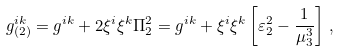<formula> <loc_0><loc_0><loc_500><loc_500>g ^ { i k } _ { ( 2 ) } = g ^ { i k } + 2 \xi ^ { i } \xi ^ { k } \Pi ^ { 2 } _ { 2 } = g ^ { i k } + \xi ^ { i } \xi ^ { k } \left [ \varepsilon ^ { 2 } _ { 2 } - \frac { 1 } { \mu ^ { 3 } _ { 3 } } \right ] \, ,</formula> 